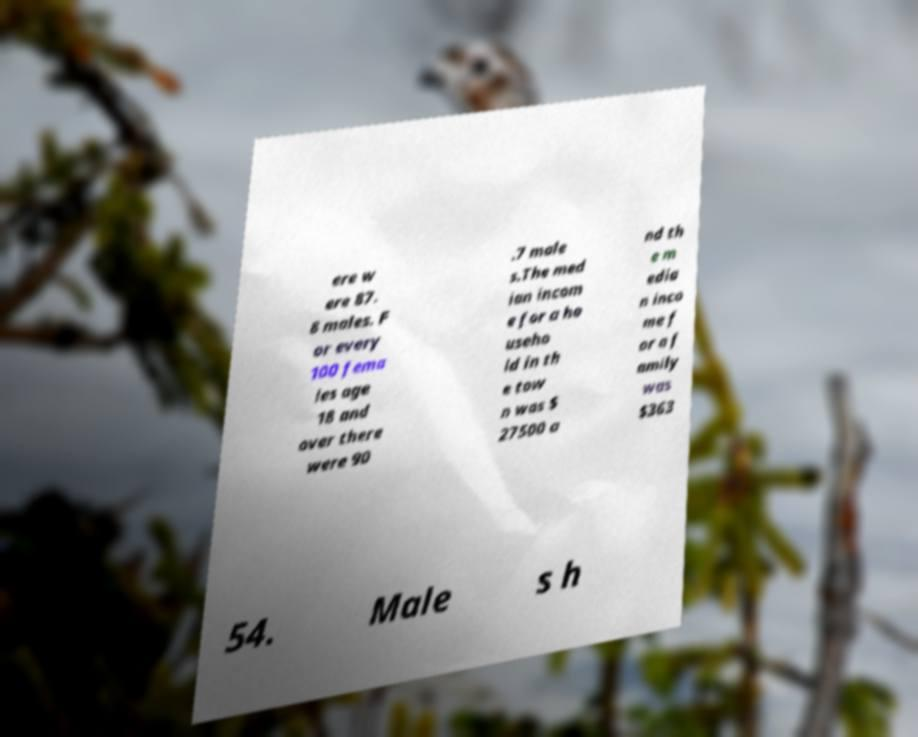Please read and relay the text visible in this image. What does it say? ere w ere 87. 8 males. F or every 100 fema les age 18 and over there were 90 .7 male s.The med ian incom e for a ho useho ld in th e tow n was $ 27500 a nd th e m edia n inco me f or a f amily was $363 54. Male s h 